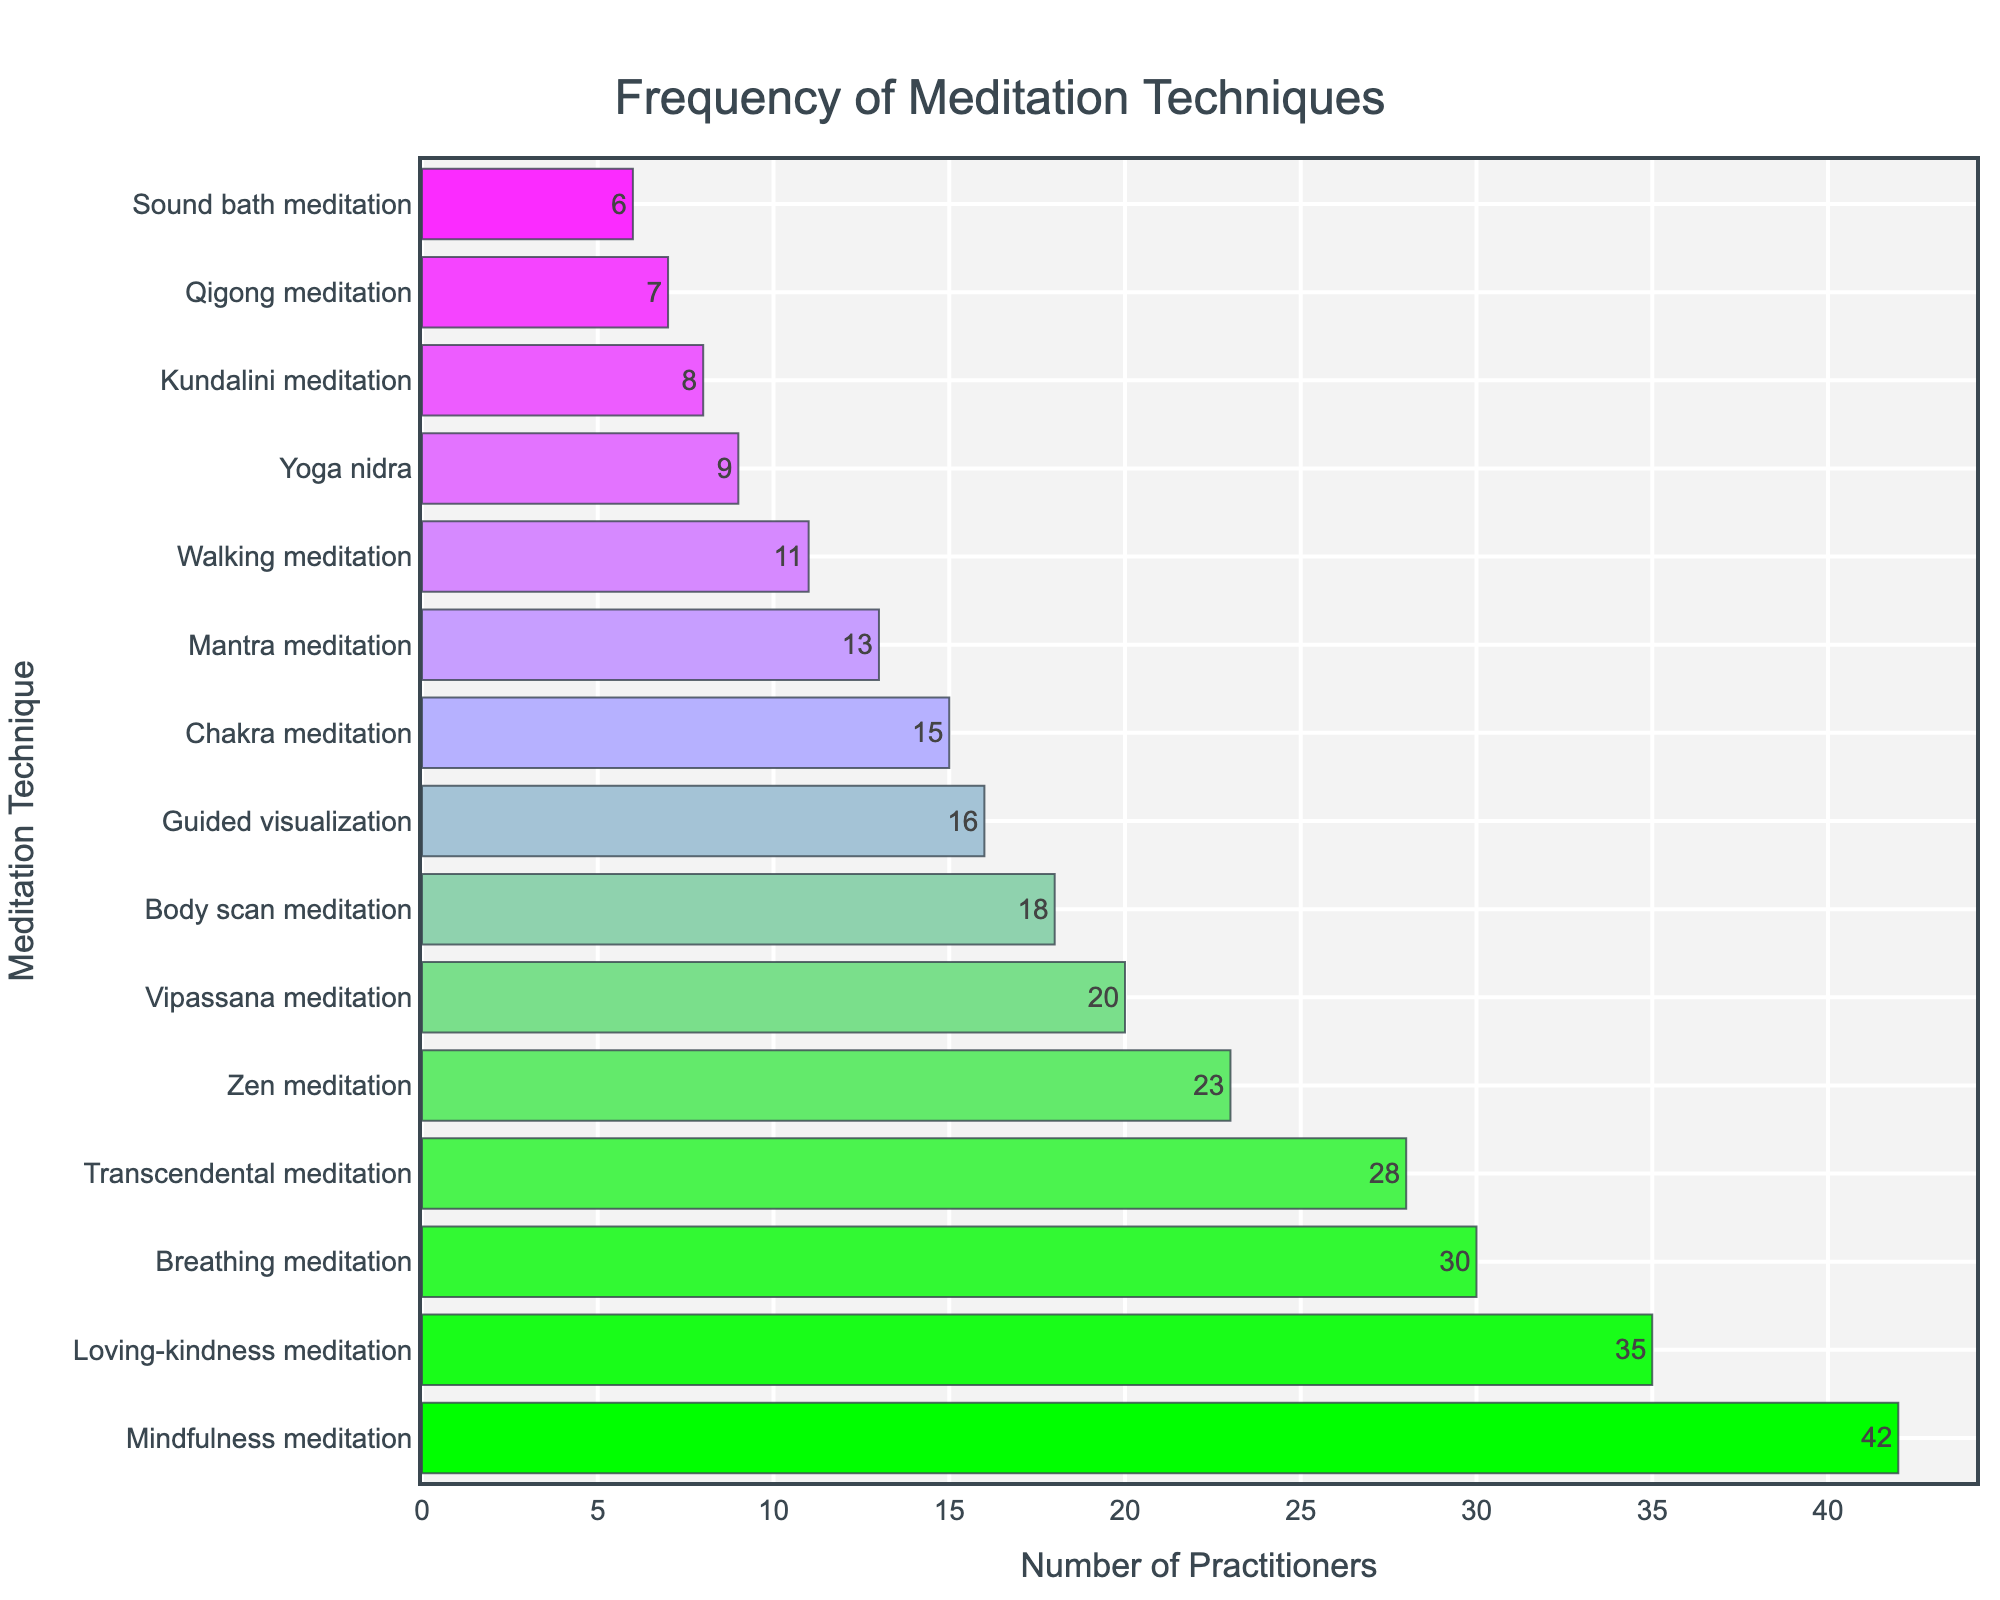Which meditation technique has the highest frequency? From the bar chart, the longest bar represents the technique with the highest frequency. It is labeled 'Mindfulness meditation' with a frequency of 42.
Answer: Mindfulness meditation Which meditation technique has the lowest frequency? By identifying the shortest bar in the chart, we see that 'Sound bath meditation' has the lowest frequency, with a value of 6.
Answer: Sound bath meditation What is the combined frequency of 'Zen meditation', 'Vipassana meditation', and 'Body scan meditation'? The frequencies of 'Zen meditation', 'Vipassana meditation', and 'Body scan meditation' are 23, 20, and 18, respectively. Adding these values gives 23 + 20 + 18 = 61.
Answer: 61 Which technique is more popular: 'Mantra meditation' or 'Walking meditation'? Comparing the lengths and values of the bars for 'Mantra meditation' (13) and 'Walking meditation' (11) shows that 'Mantra meditation' has a higher frequency.
Answer: Mantra meditation How much more frequent is 'Breathing meditation' compared to 'Kundalini meditation'? 'Breathing meditation' has a frequency of 30, while 'Kundalini meditation' has 8. The difference is 30 - 8 = 22.
Answer: 22 Which technique has a frequency closest to the median frequency value depicted? There are 15 techniques listed, so the median corresponds to the 8th value in the sorted list, which is 'Mantra meditation' with a frequency of 13.
Answer: Mantra meditation What is the average frequency of the top 3 most practiced techniques? The top 3 techniques are 'Mindfulness meditation' (42), 'Loving-kindness meditation' (35), and 'Breathing meditation' (30). Their average frequency is (42 + 35 + 30) / 3 = 107 / 3 ≈ 35.67.
Answer: 35.67 Which techniques have a frequency greater than 20 but less than 30? The techniques within this range are 'Transcendental meditation' (28) and 'Zen meditation' (23).
Answer: Transcendental meditation, Zen meditation What is the total frequency of all meditation techniques excluding the two least practiced ones? Excluding 'Qigong meditation' (7) and 'Sound bath meditation' (6), we sum the remaining frequencies: 42 + 35 + 30 + 28 + 23 + 20 + 18 + 15 + 13 + 11 + 9 + 8 + 16 = 268.
Answer: 268 Which has greater frequency: the sum of 'Chakra meditation' and 'Guided visualization', or 'Transcendental meditation'? 'Chakra meditation' and 'Guided visualization' sum to 15 + 16 = 31, while 'Transcendental meditation' has 28. Therefore, 31 is greater than 28.
Answer: Chakra meditation and Guided visualization 